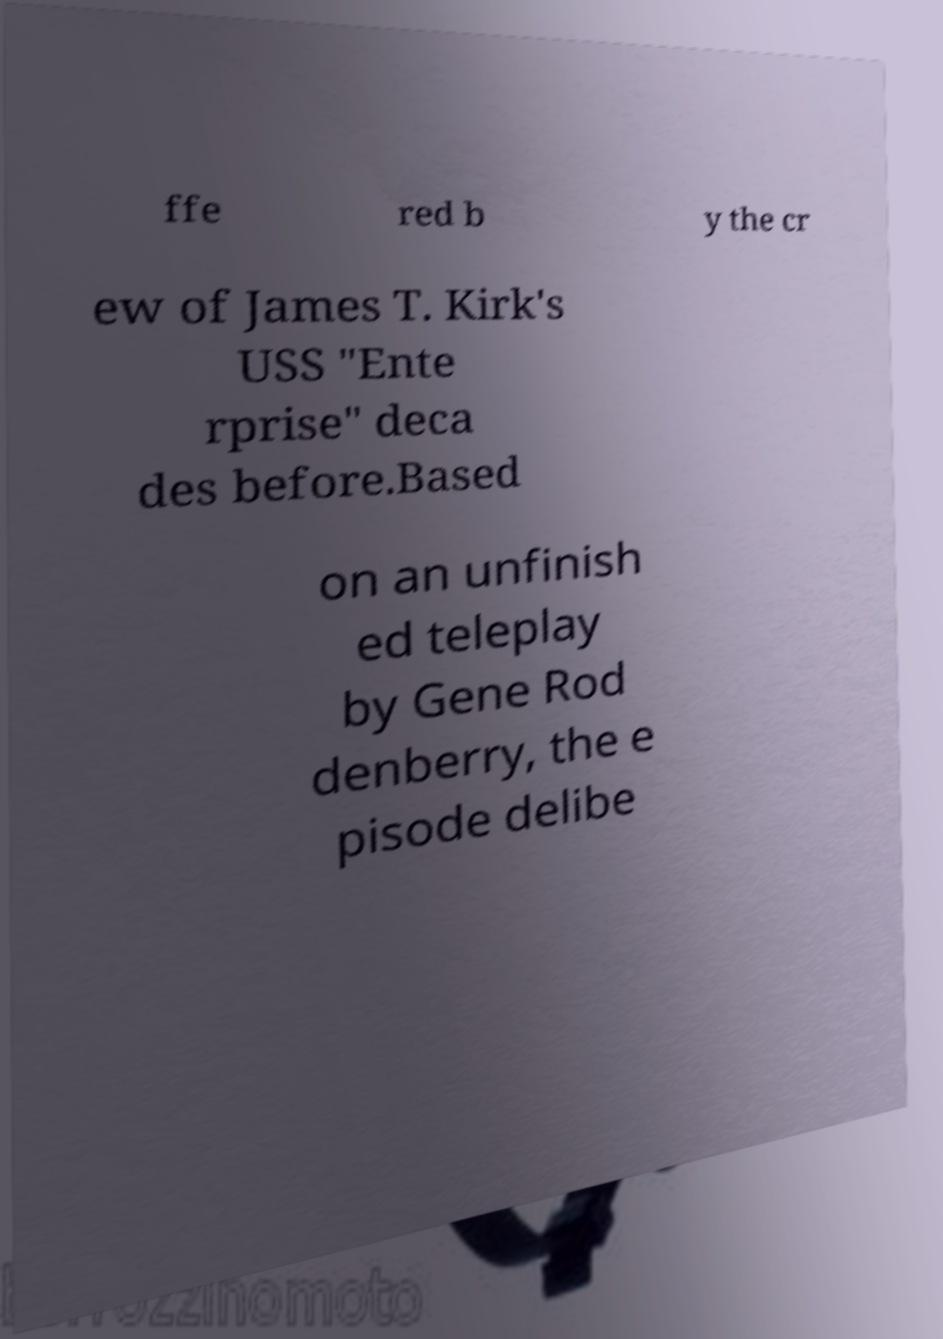What messages or text are displayed in this image? I need them in a readable, typed format. ffe red b y the cr ew of James T. Kirk's USS "Ente rprise" deca des before.Based on an unfinish ed teleplay by Gene Rod denberry, the e pisode delibe 